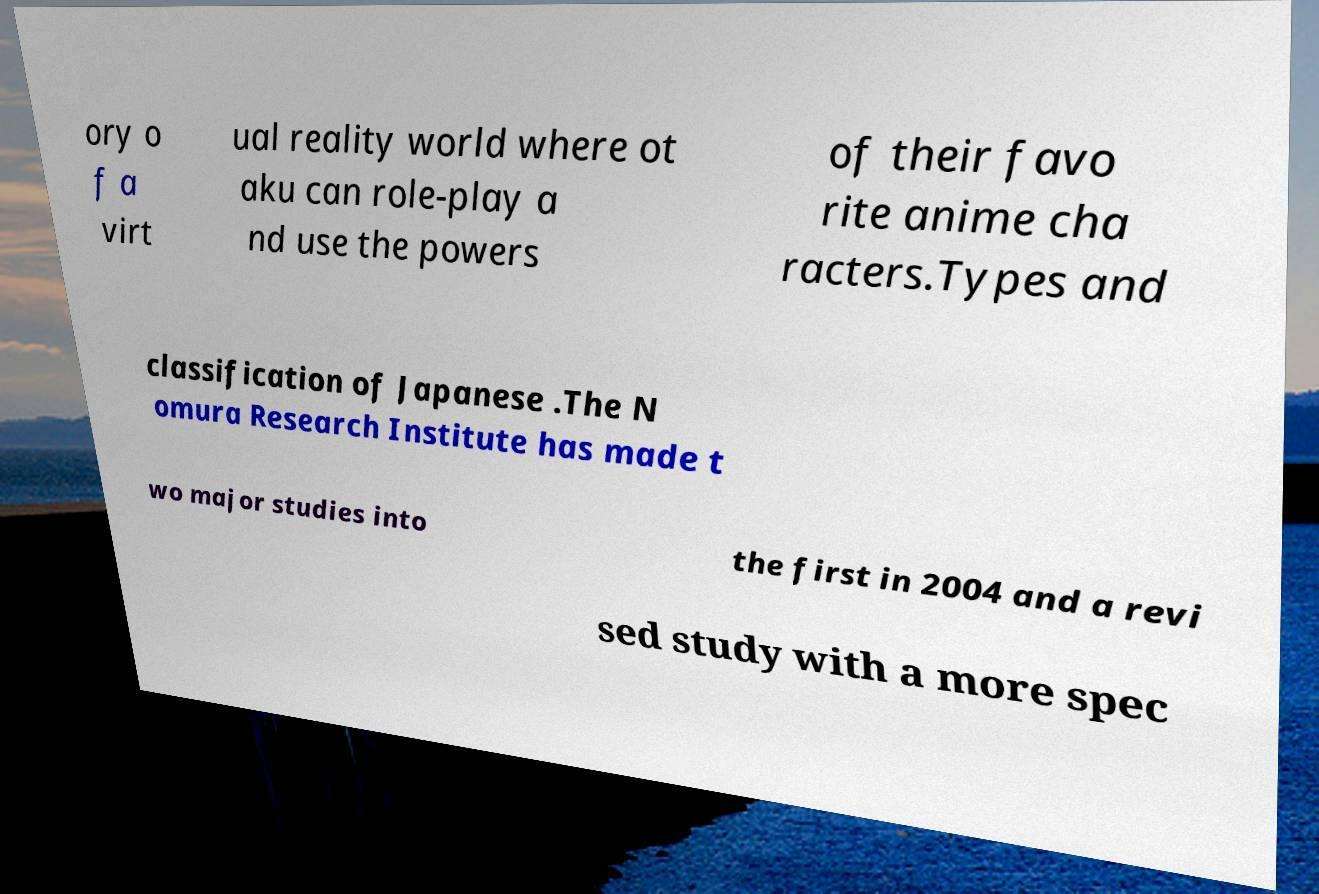Can you accurately transcribe the text from the provided image for me? ory o f a virt ual reality world where ot aku can role-play a nd use the powers of their favo rite anime cha racters.Types and classification of Japanese .The N omura Research Institute has made t wo major studies into the first in 2004 and a revi sed study with a more spec 